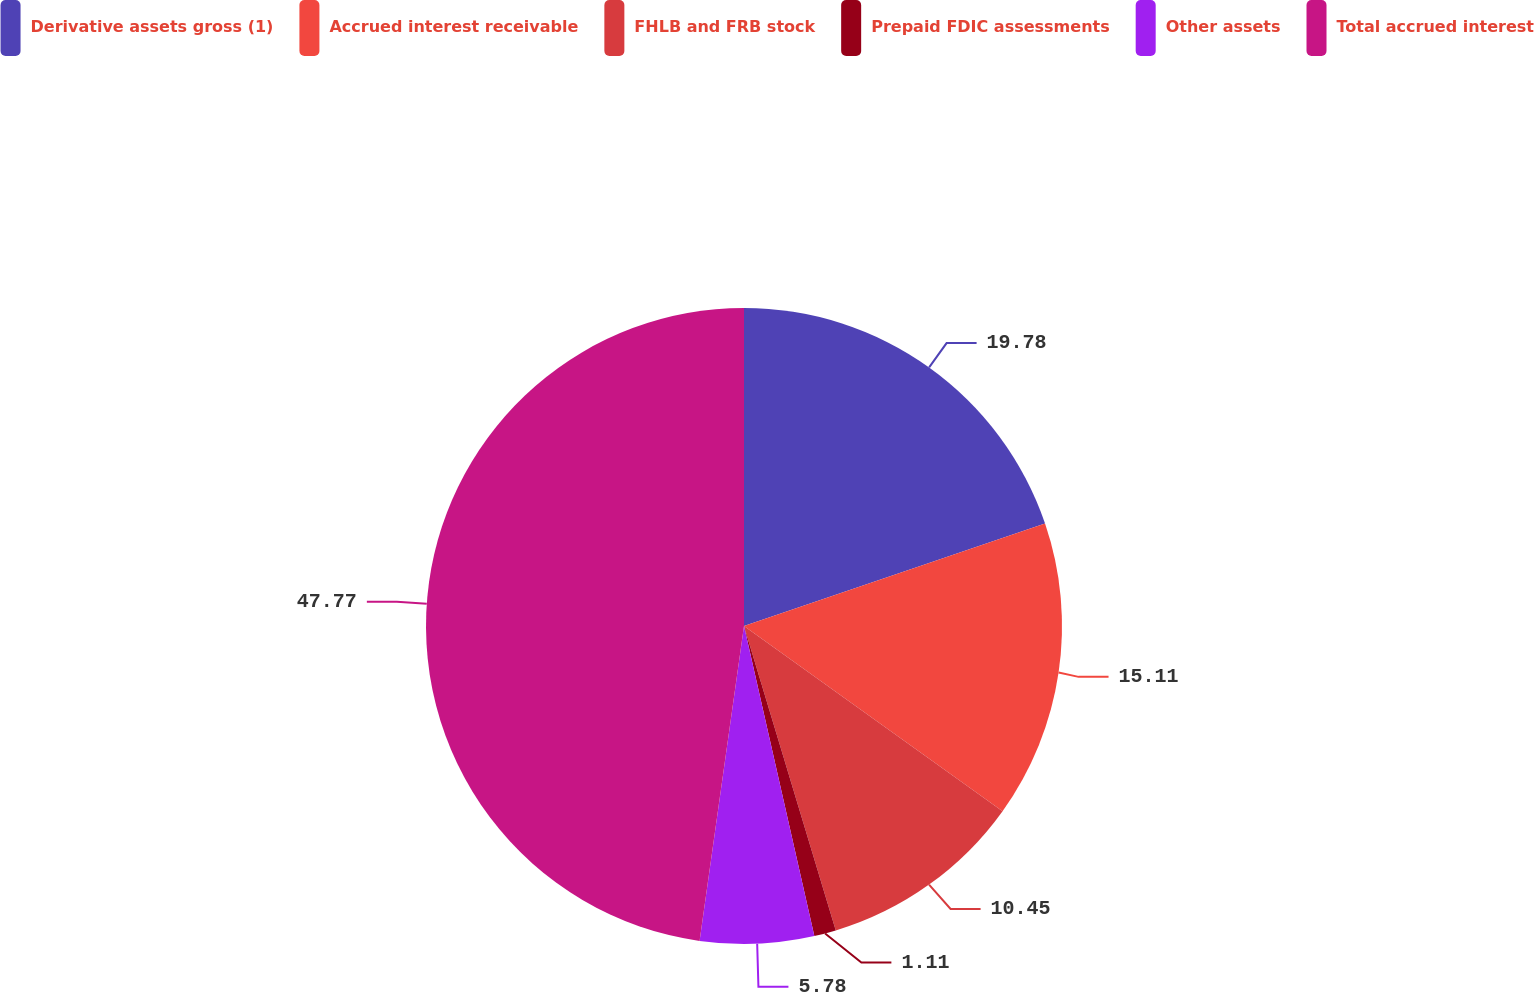<chart> <loc_0><loc_0><loc_500><loc_500><pie_chart><fcel>Derivative assets gross (1)<fcel>Accrued interest receivable<fcel>FHLB and FRB stock<fcel>Prepaid FDIC assessments<fcel>Other assets<fcel>Total accrued interest<nl><fcel>19.78%<fcel>15.11%<fcel>10.45%<fcel>1.11%<fcel>5.78%<fcel>47.77%<nl></chart> 